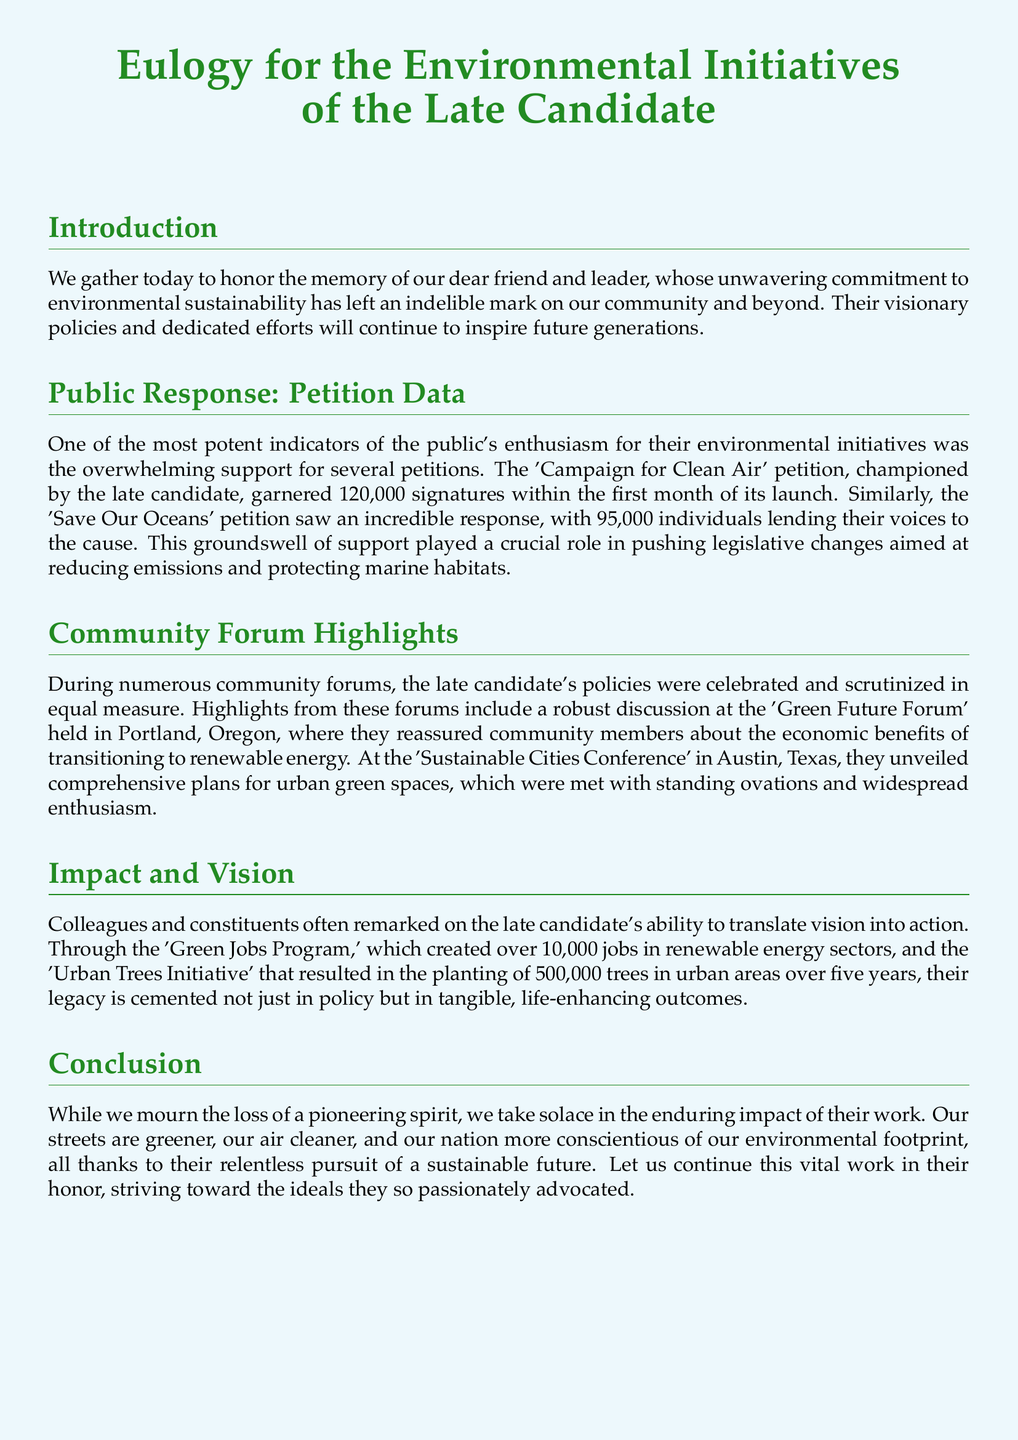what was the total number of signatures for the 'Campaign for Clean Air' petition? The document states that the 'Campaign for Clean Air' petition garnered 120,000 signatures.
Answer: 120,000 how many individuals supported the 'Save Our Oceans' petition? The document indicates that the 'Save Our Oceans' petition received support from 95,000 individuals.
Answer: 95,000 what initiative created over 10,000 jobs in renewable energy sectors? The document refers to the 'Green Jobs Program' as the initiative that created over 10,000 jobs.
Answer: Green Jobs Program which city held the 'Sustainable Cities Conference'? The document mentions that the 'Sustainable Cities Conference' was held in Austin, Texas.
Answer: Austin, Texas how many trees were planted under the 'Urban Trees Initiative'? According to the document, the 'Urban Trees Initiative' resulted in the planting of 500,000 trees.
Answer: 500,000 what was a major theme discussed at the 'Green Future Forum'? The document highlights that a major theme at the 'Green Future Forum' was the economic benefits of transitioning to renewable energy.
Answer: economic benefits what is the document's primary purpose? The primary purpose of the document is to honor the late candidate's commitment to environmental sustainability and their legacy.
Answer: to honor the late candidate what color is used for the title text? The document specifies that the title text is colored forest green.
Answer: forest green what kind of impact did the late candidate have on the community according to the document? The document states that the late candidate had a significant impact on making streets greener and air cleaner.
Answer: significant impact 